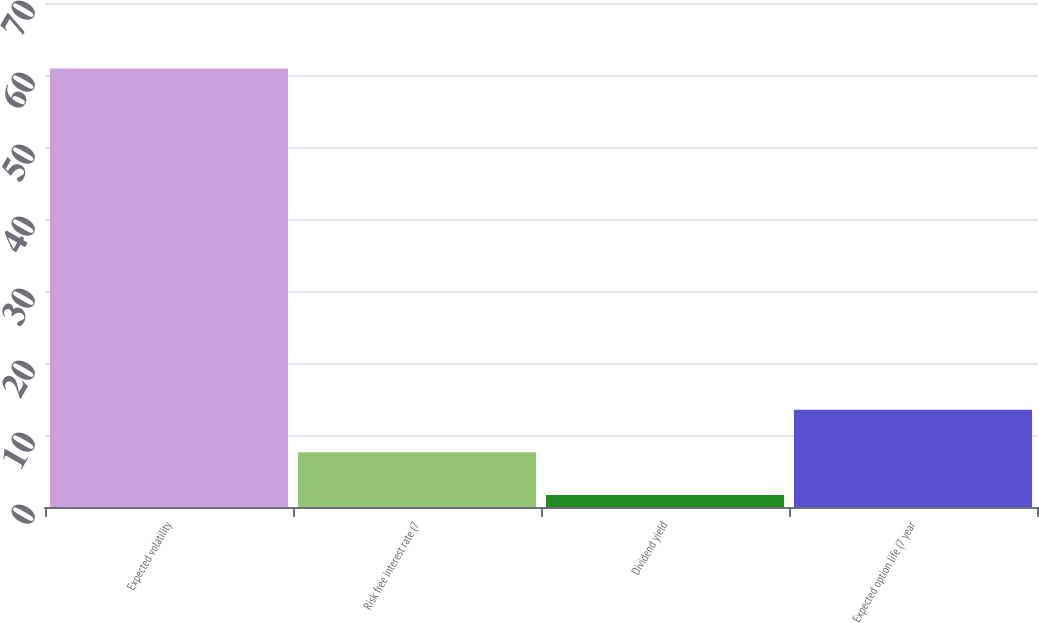Convert chart. <chart><loc_0><loc_0><loc_500><loc_500><bar_chart><fcel>Expected volatility<fcel>Risk free interest rate (7<fcel>Dividend yield<fcel>Expected option life (7 year<nl><fcel>60.9<fcel>7.6<fcel>1.68<fcel>13.52<nl></chart> 